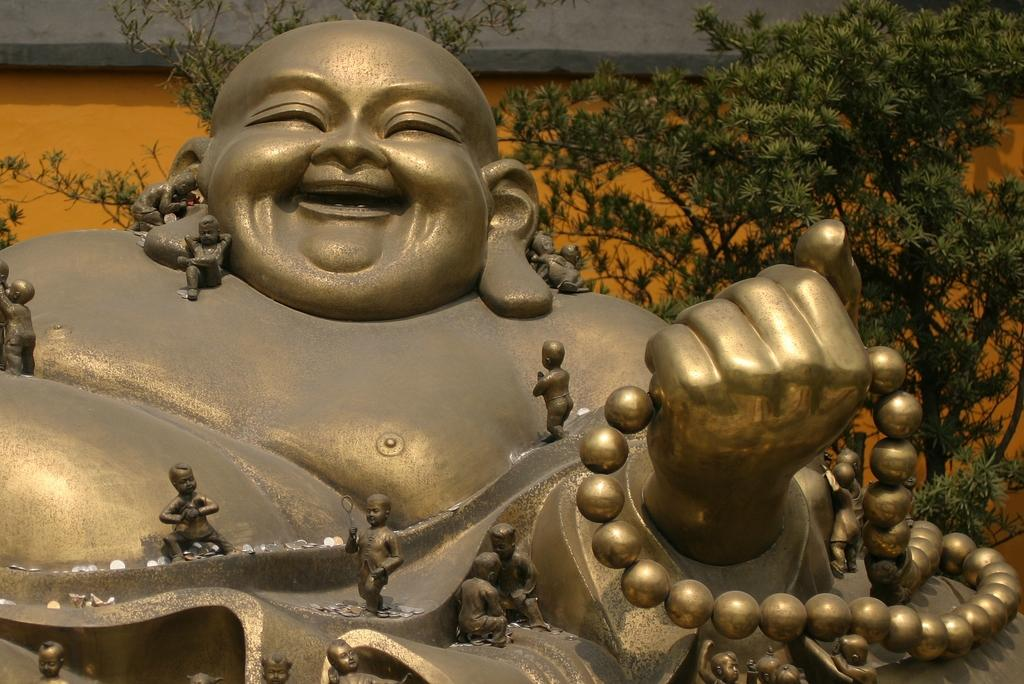What is the main subject of the image? There is a laughing Buddha statue in the image. What is the color of the statue? The statue is in gold color. What can be seen on the right side of the image? There are trees on the right side of the image. What is on the left side of the image? There is a wall on the left side of the image. What is the color of the wall? The wall is in orange color. How many rings are visible on the laughing Buddha's fingers in the image? There are no rings visible on the laughing Buddha's fingers in the image. Is there any snow present in the image? There is no snow present in the image. 